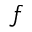Convert formula to latex. <formula><loc_0><loc_0><loc_500><loc_500>f</formula> 